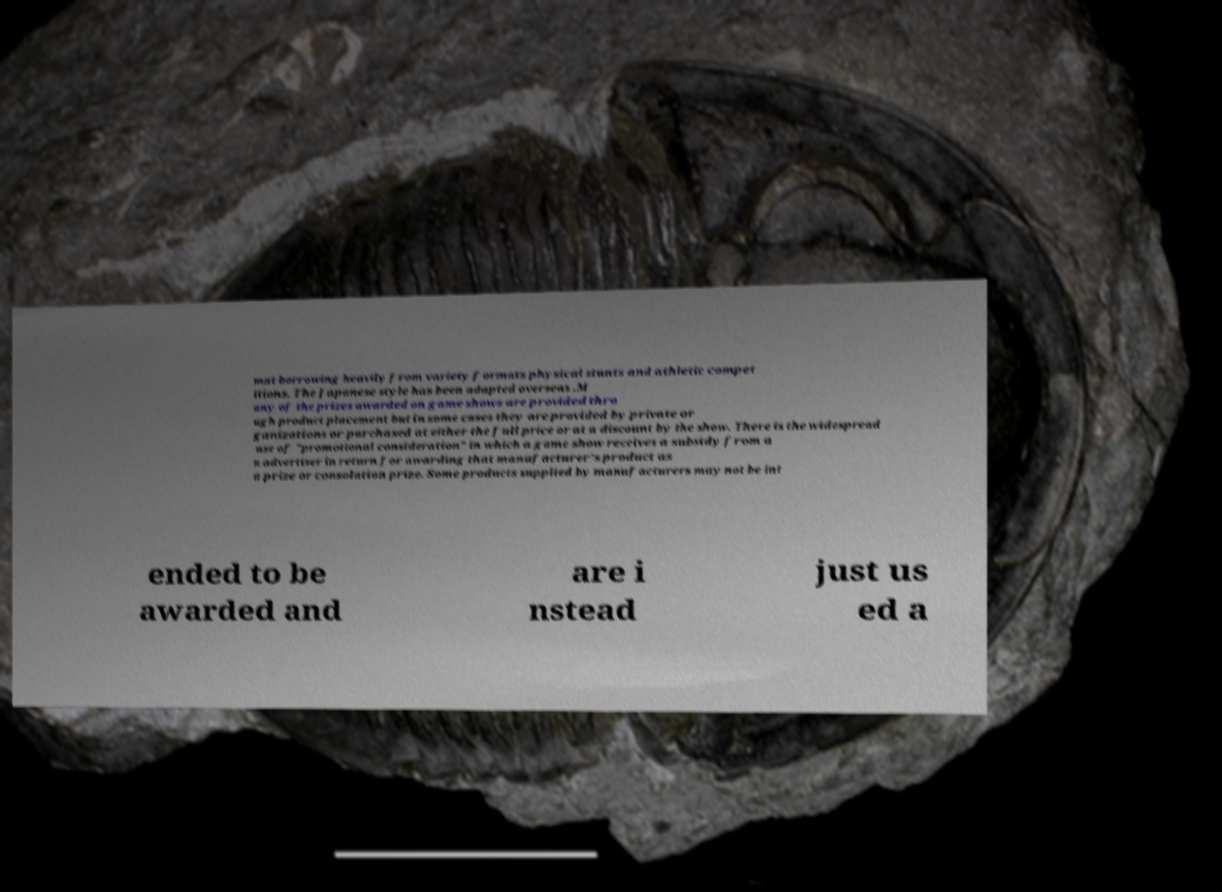Please read and relay the text visible in this image. What does it say? mat borrowing heavily from variety formats physical stunts and athletic compet itions. The Japanese style has been adapted overseas .M any of the prizes awarded on game shows are provided thro ugh product placement but in some cases they are provided by private or ganizations or purchased at either the full price or at a discount by the show. There is the widespread use of "promotional consideration" in which a game show receives a subsidy from a n advertiser in return for awarding that manufacturer's product as a prize or consolation prize. Some products supplied by manufacturers may not be int ended to be awarded and are i nstead just us ed a 